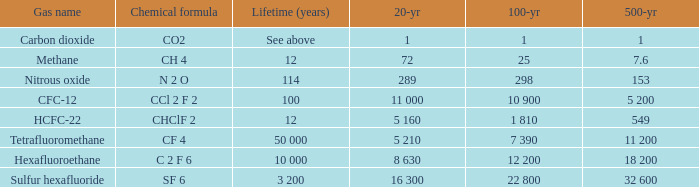What is the lifespan (in years) of the chemical compound ch4? 12.0. 